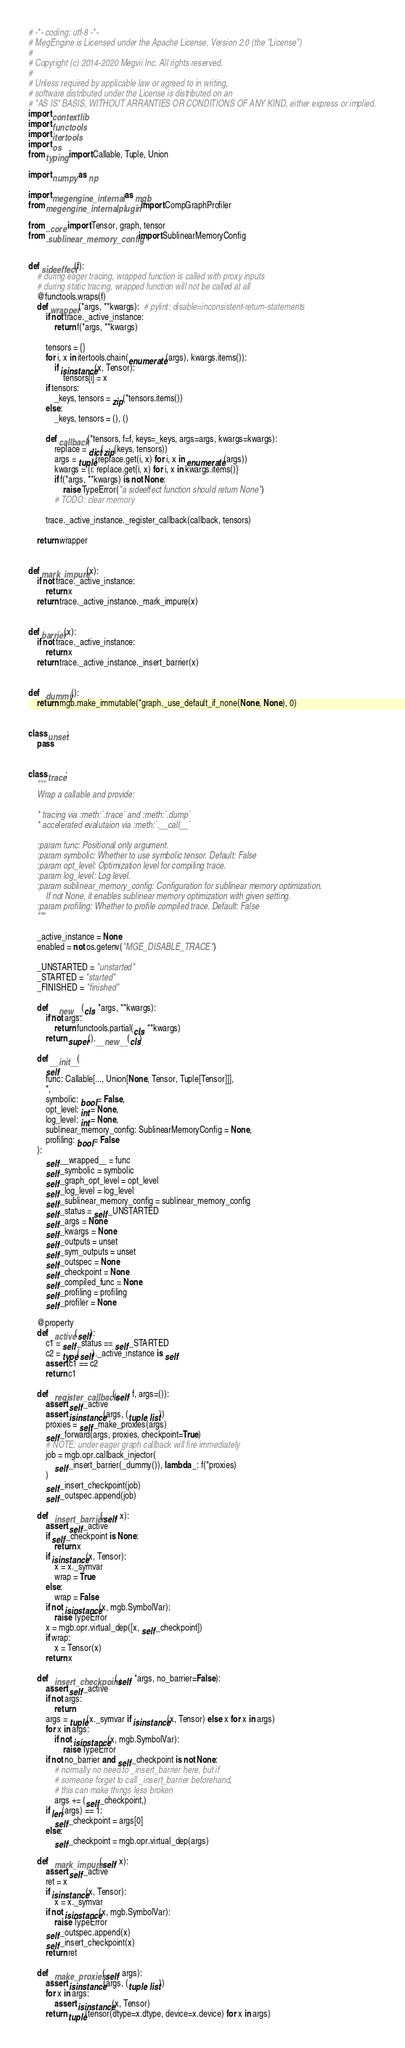Convert code to text. <code><loc_0><loc_0><loc_500><loc_500><_Python_># -*- coding: utf-8 -*-
# MegEngine is Licensed under the Apache License, Version 2.0 (the "License")
#
# Copyright (c) 2014-2020 Megvii Inc. All rights reserved.
#
# Unless required by applicable law or agreed to in writing,
# software distributed under the License is distributed on an
# "AS IS" BASIS, WITHOUT ARRANTIES OR CONDITIONS OF ANY KIND, either express or implied.
import contextlib
import functools
import itertools
import os
from typing import Callable, Tuple, Union

import numpy as np

import megengine._internal as mgb
from megengine._internal.plugin import CompGraphProfiler

from ..core import Tensor, graph, tensor
from .sublinear_memory_config import SublinearMemoryConfig


def sideeffect(f):
    # during eager tracing, wrapped function is called with proxy inputs
    # during static tracing, wrapped function will not be called at all
    @functools.wraps(f)
    def wrapper(*args, **kwargs):  # pylint: disable=inconsistent-return-statements
        if not trace._active_instance:
            return f(*args, **kwargs)

        tensors = {}
        for i, x in itertools.chain(enumerate(args), kwargs.items()):
            if isinstance(x, Tensor):
                tensors[i] = x
        if tensors:
            _keys, tensors = zip(*tensors.items())
        else:
            _keys, tensors = (), ()

        def callback(*tensors, f=f, keys=_keys, args=args, kwargs=kwargs):
            replace = dict(zip(keys, tensors))
            args = tuple(replace.get(i, x) for i, x in enumerate(args))
            kwargs = {i: replace.get(i, x) for i, x in kwargs.items()}
            if f(*args, **kwargs) is not None:
                raise TypeError("a sideeffect function should return None")
            # TODO: clear memory

        trace._active_instance._register_callback(callback, tensors)

    return wrapper


def mark_impure(x):
    if not trace._active_instance:
        return x
    return trace._active_instance._mark_impure(x)


def barrier(x):
    if not trace._active_instance:
        return x
    return trace._active_instance._insert_barrier(x)


def _dummy():
    return mgb.make_immutable(*graph._use_default_if_none(None, None), 0)


class unset:
    pass


class trace:
    """
    Wrap a callable and provide:

    * tracing via :meth:`.trace` and :meth:`.dump`
    * accelerated evalutaion via :meth:`.__call__`

    :param func: Positional only argument.
    :param symbolic: Whether to use symbolic tensor. Default: False
    :param opt_level: Optimization level for compiling trace.
    :param log_level: Log level.
    :param sublinear_memory_config: Configuration for sublinear memory optimization.
        If not None, it enables sublinear memory optimization with given setting.
    :param profiling: Whether to profile compiled trace. Default: False
    """

    _active_instance = None
    enabled = not os.getenv("MGE_DISABLE_TRACE")

    _UNSTARTED = "unstarted"
    _STARTED = "started"
    _FINISHED = "finished"

    def __new__(cls, *args, **kwargs):
        if not args:
            return functools.partial(cls, **kwargs)
        return super().__new__(cls)

    def __init__(
        self,
        func: Callable[..., Union[None, Tensor, Tuple[Tensor]]],
        *,
        symbolic: bool = False,
        opt_level: int = None,
        log_level: int = None,
        sublinear_memory_config: SublinearMemoryConfig = None,
        profiling: bool = False
    ):
        self.__wrapped__ = func
        self._symbolic = symbolic
        self._graph_opt_level = opt_level
        self._log_level = log_level
        self._sublinear_memory_config = sublinear_memory_config
        self._status = self._UNSTARTED
        self._args = None
        self._kwargs = None
        self._outputs = unset
        self._sym_outputs = unset
        self._outspec = None
        self._checkpoint = None
        self._compiled_func = None
        self._profiling = profiling
        self._profiler = None

    @property
    def _active(self):
        c1 = self._status == self._STARTED
        c2 = type(self)._active_instance is self
        assert c1 == c2
        return c1

    def _register_callback(self, f, args=()):
        assert self._active
        assert isinstance(args, (tuple, list))
        proxies = self._make_proxies(args)
        self._forward(args, proxies, checkpoint=True)
        # NOTE: under eager graph callback will fire immediately
        job = mgb.opr.callback_injector(
            self._insert_barrier(_dummy()), lambda _: f(*proxies)
        )
        self._insert_checkpoint(job)
        self._outspec.append(job)

    def _insert_barrier(self, x):
        assert self._active
        if self._checkpoint is None:
            return x
        if isinstance(x, Tensor):
            x = x._symvar
            wrap = True
        else:
            wrap = False
        if not isinstance(x, mgb.SymbolVar):
            raise TypeError
        x = mgb.opr.virtual_dep([x, self._checkpoint])
        if wrap:
            x = Tensor(x)
        return x

    def _insert_checkpoint(self, *args, no_barrier=False):
        assert self._active
        if not args:
            return
        args = tuple(x._symvar if isinstance(x, Tensor) else x for x in args)
        for x in args:
            if not isinstance(x, mgb.SymbolVar):
                raise TypeError
        if not no_barrier and self._checkpoint is not None:
            # normally no need to _insert_barrier here, but if
            # someone forget to call _insert_barrier beforehand,
            # this can make things less broken
            args += (self._checkpoint,)
        if len(args) == 1:
            self._checkpoint = args[0]
        else:
            self._checkpoint = mgb.opr.virtual_dep(args)

    def _mark_impure(self, x):
        assert self._active
        ret = x
        if isinstance(x, Tensor):
            x = x._symvar
        if not isinstance(x, mgb.SymbolVar):
            raise TypeError
        self._outspec.append(x)
        self._insert_checkpoint(x)
        return ret

    def _make_proxies(self, args):
        assert isinstance(args, (tuple, list))
        for x in args:
            assert isinstance(x, Tensor)
        return tuple(tensor(dtype=x.dtype, device=x.device) for x in args)
</code> 